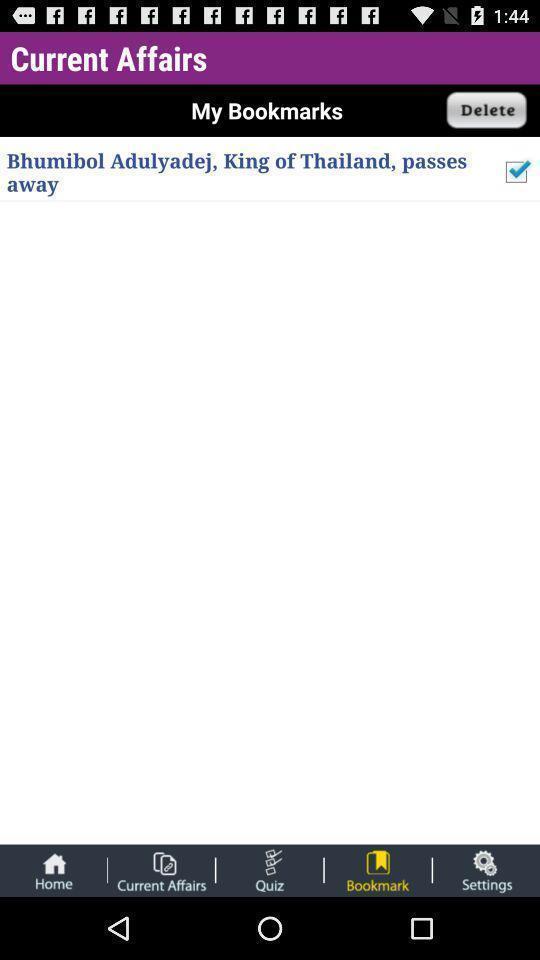Describe the content in this image. Screen displaying the contents of starred messages. 